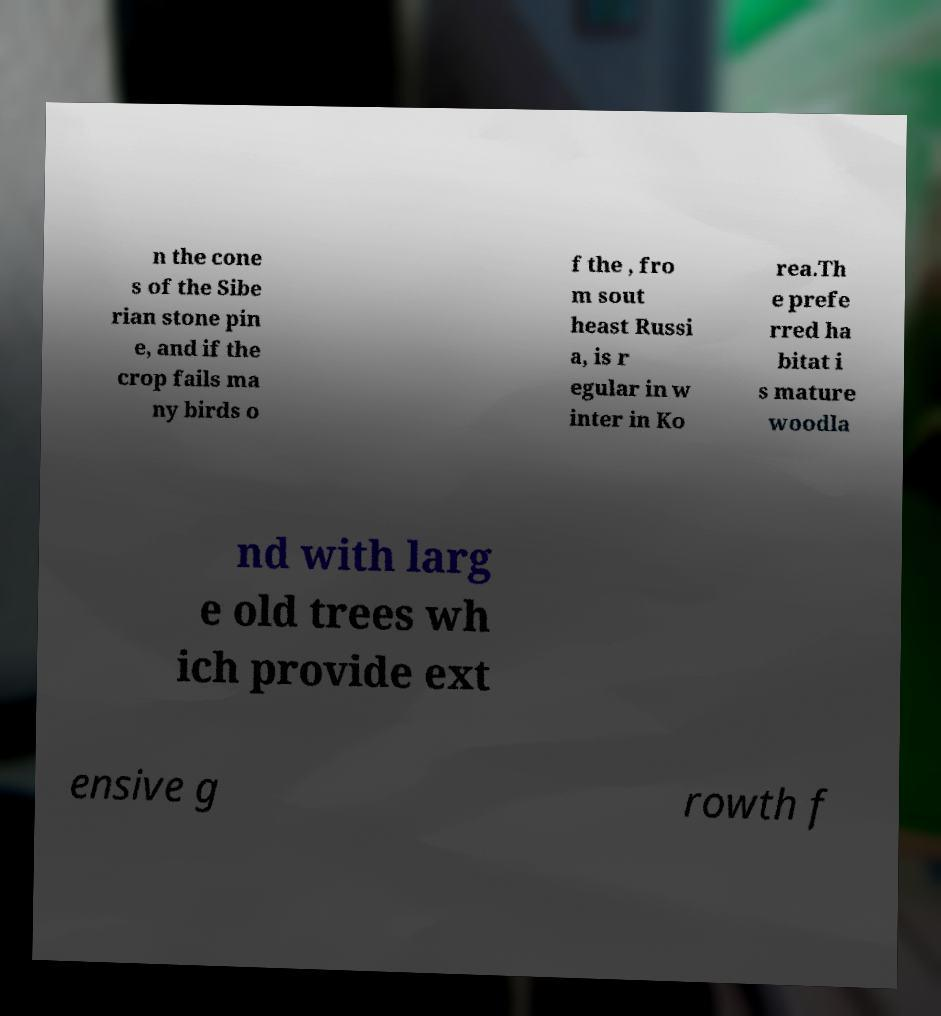There's text embedded in this image that I need extracted. Can you transcribe it verbatim? n the cone s of the Sibe rian stone pin e, and if the crop fails ma ny birds o f the , fro m sout heast Russi a, is r egular in w inter in Ko rea.Th e prefe rred ha bitat i s mature woodla nd with larg e old trees wh ich provide ext ensive g rowth f 